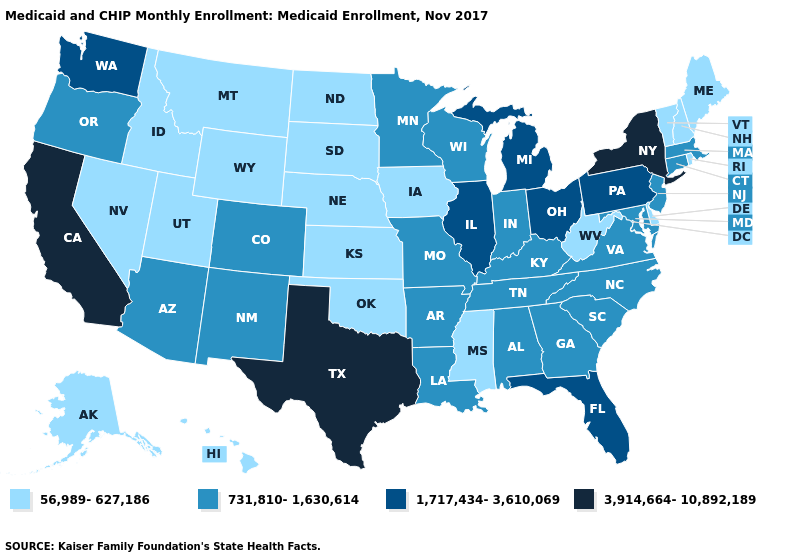What is the value of West Virginia?
Answer briefly. 56,989-627,186. Does the first symbol in the legend represent the smallest category?
Keep it brief. Yes. Does Illinois have the highest value in the USA?
Quick response, please. No. Among the states that border Tennessee , does Mississippi have the highest value?
Write a very short answer. No. Which states have the lowest value in the USA?
Answer briefly. Alaska, Delaware, Hawaii, Idaho, Iowa, Kansas, Maine, Mississippi, Montana, Nebraska, Nevada, New Hampshire, North Dakota, Oklahoma, Rhode Island, South Dakota, Utah, Vermont, West Virginia, Wyoming. What is the value of Minnesota?
Give a very brief answer. 731,810-1,630,614. What is the value of New York?
Quick response, please. 3,914,664-10,892,189. Among the states that border South Dakota , does Montana have the lowest value?
Concise answer only. Yes. Does North Dakota have the same value as Maryland?
Quick response, please. No. What is the value of Michigan?
Short answer required. 1,717,434-3,610,069. Does the map have missing data?
Give a very brief answer. No. What is the lowest value in the USA?
Write a very short answer. 56,989-627,186. Does Vermont have the highest value in the Northeast?
Quick response, please. No. Does New Jersey have the lowest value in the USA?
Answer briefly. No. What is the lowest value in the USA?
Answer briefly. 56,989-627,186. 